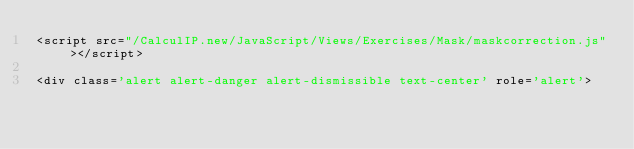<code> <loc_0><loc_0><loc_500><loc_500><_PHP_><script src="/CalculIP.new/JavaScript/Views/Exercises/Mask/maskcorrection.js"></script>

<div class='alert alert-danger alert-dismissible text-center' role='alert'></code> 